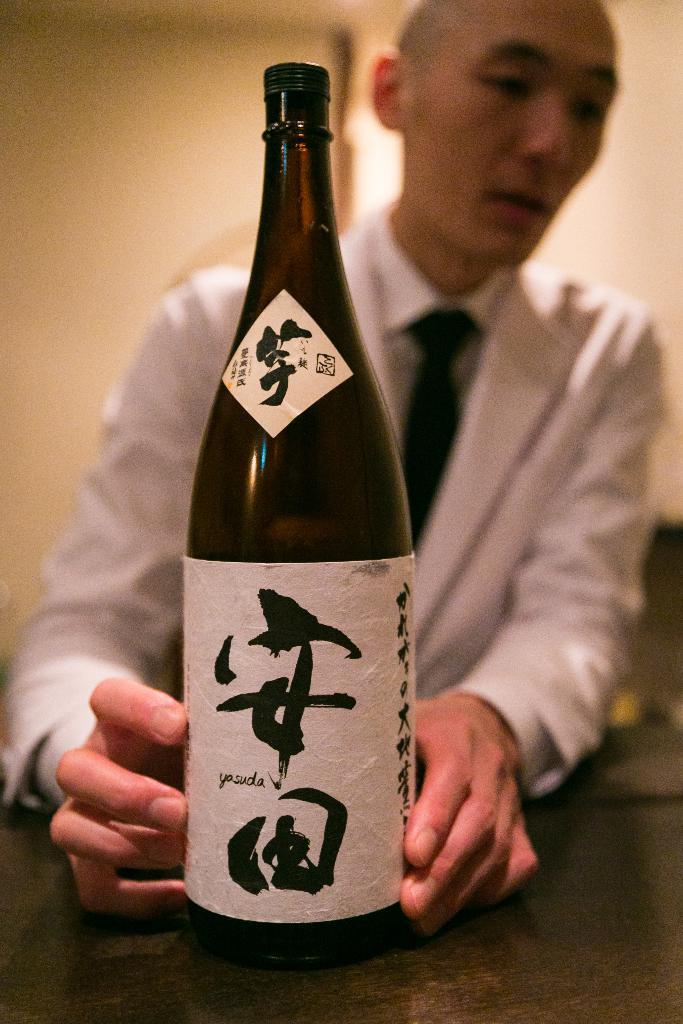What is present in the image? There is a man in the image. Can you describe the man's clothing? The man is wearing a white shirt. What other object can be seen in the image? There is a bottle in the image. What type of company does the man represent in the image? There is no indication in the image that the man represents any company. Can you see any bats flying around the man in the image? There are no bats visible in the image. 